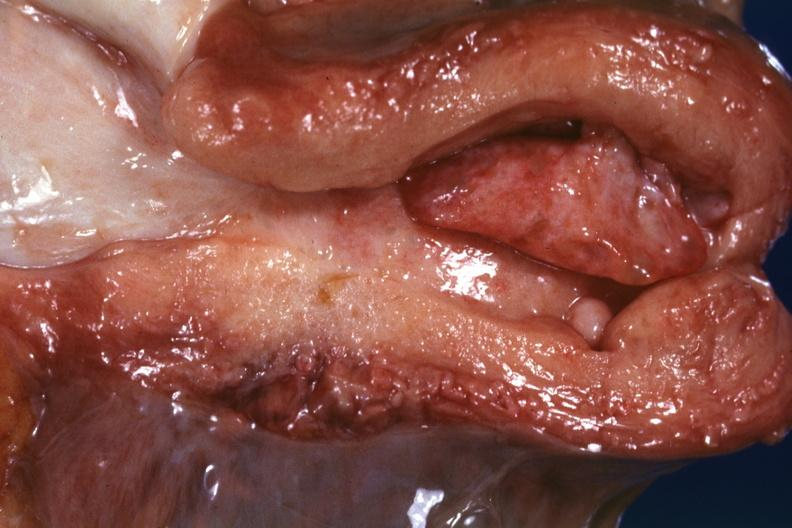what is present?
Answer the question using a single word or phrase. Female reproductive 